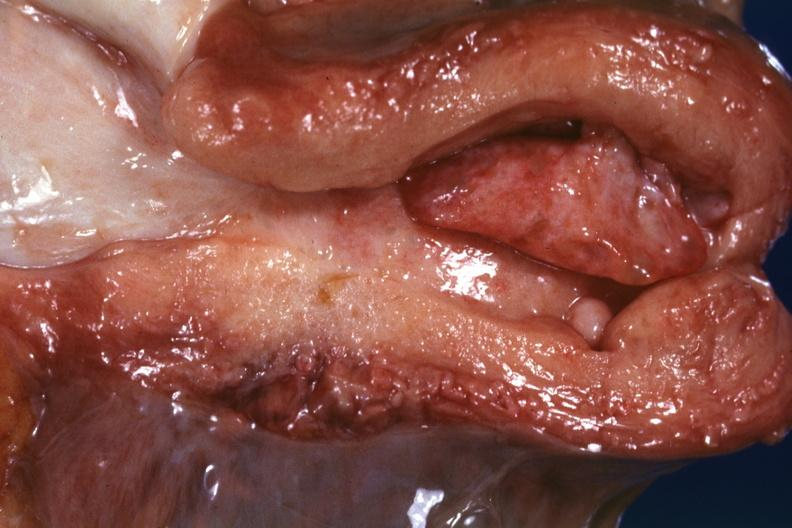what is present?
Answer the question using a single word or phrase. Female reproductive 